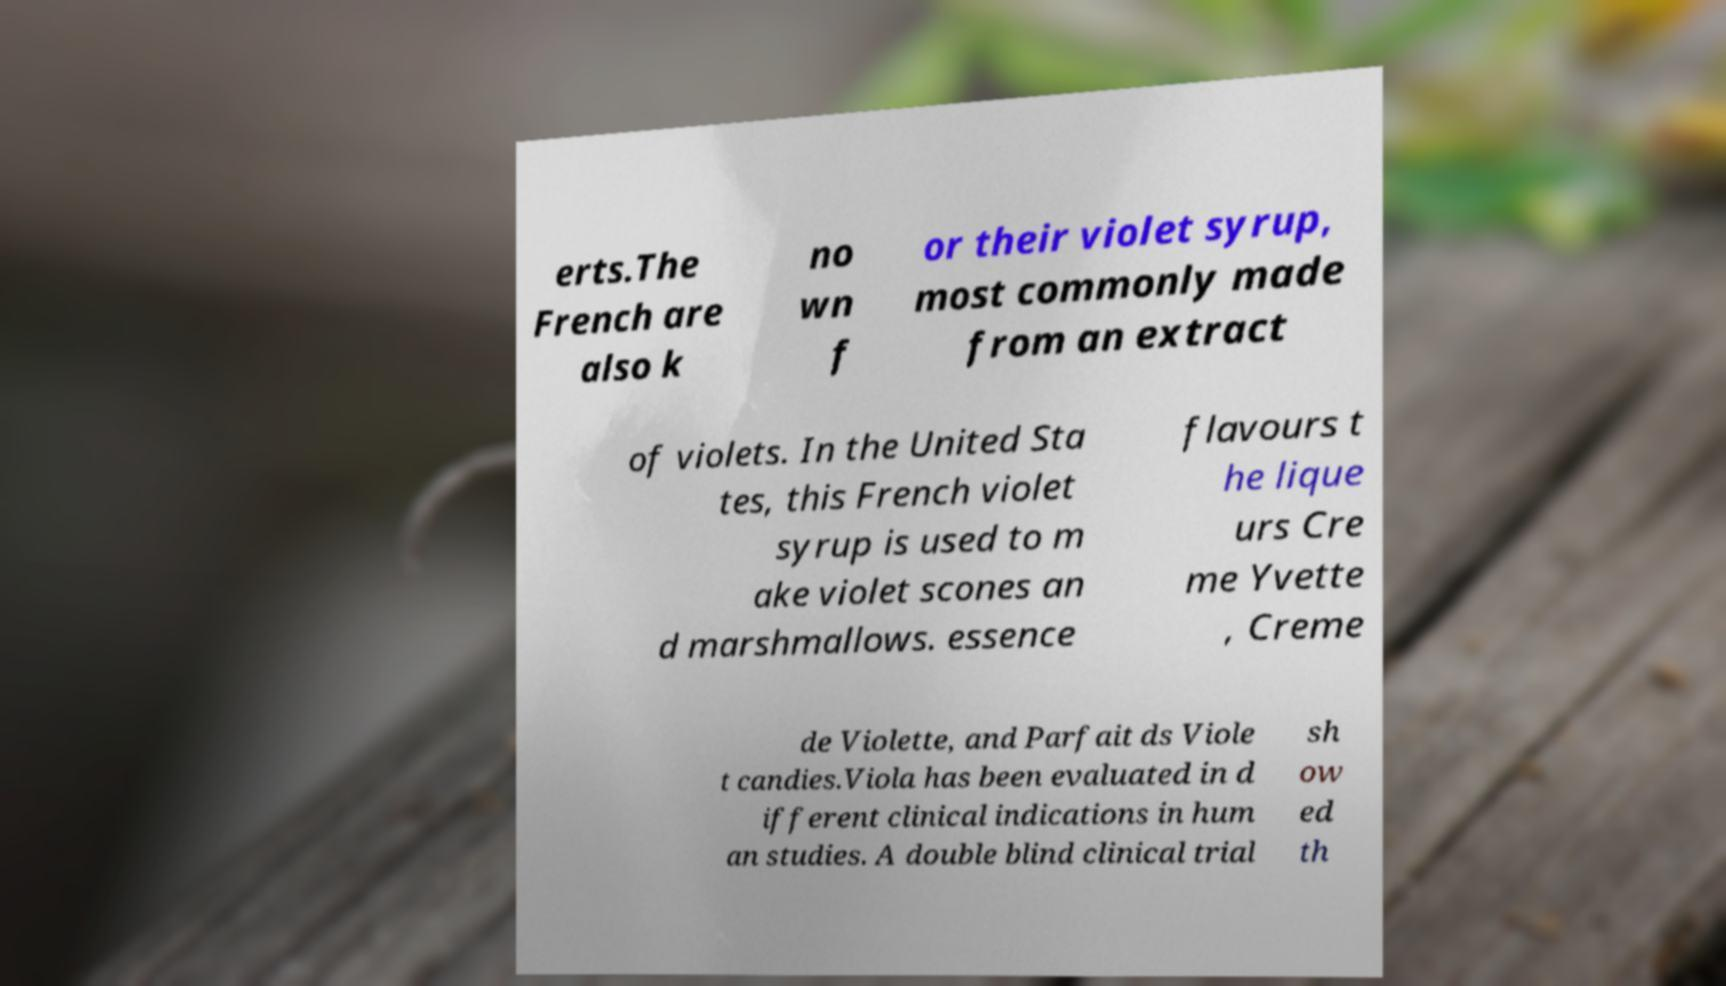For documentation purposes, I need the text within this image transcribed. Could you provide that? erts.The French are also k no wn f or their violet syrup, most commonly made from an extract of violets. In the United Sta tes, this French violet syrup is used to m ake violet scones an d marshmallows. essence flavours t he lique urs Cre me Yvette , Creme de Violette, and Parfait ds Viole t candies.Viola has been evaluated in d ifferent clinical indications in hum an studies. A double blind clinical trial sh ow ed th 